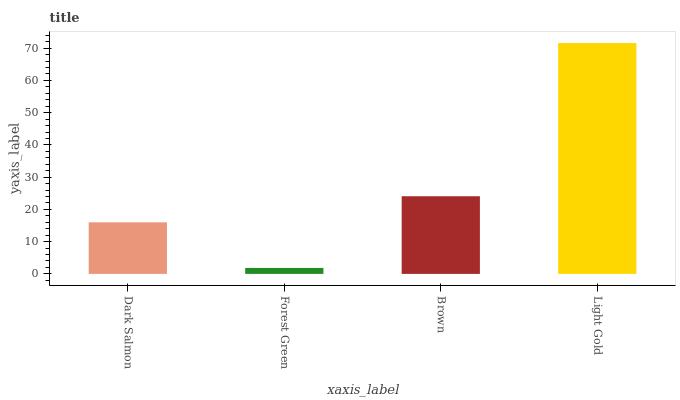Is Forest Green the minimum?
Answer yes or no. Yes. Is Light Gold the maximum?
Answer yes or no. Yes. Is Brown the minimum?
Answer yes or no. No. Is Brown the maximum?
Answer yes or no. No. Is Brown greater than Forest Green?
Answer yes or no. Yes. Is Forest Green less than Brown?
Answer yes or no. Yes. Is Forest Green greater than Brown?
Answer yes or no. No. Is Brown less than Forest Green?
Answer yes or no. No. Is Brown the high median?
Answer yes or no. Yes. Is Dark Salmon the low median?
Answer yes or no. Yes. Is Dark Salmon the high median?
Answer yes or no. No. Is Light Gold the low median?
Answer yes or no. No. 